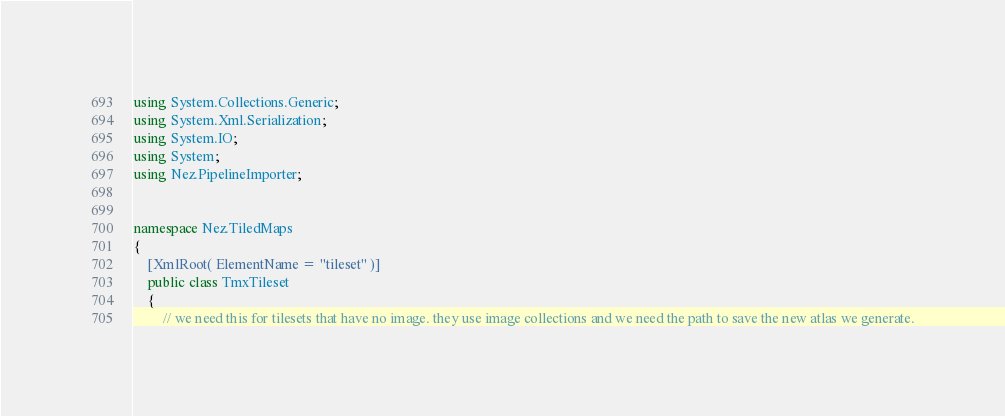<code> <loc_0><loc_0><loc_500><loc_500><_C#_>using System.Collections.Generic;
using System.Xml.Serialization;
using System.IO;
using System;
using Nez.PipelineImporter;


namespace Nez.TiledMaps
{
	[XmlRoot( ElementName = "tileset" )]
	public class TmxTileset
	{
		// we need this for tilesets that have no image. they use image collections and we need the path to save the new atlas we generate.</code> 